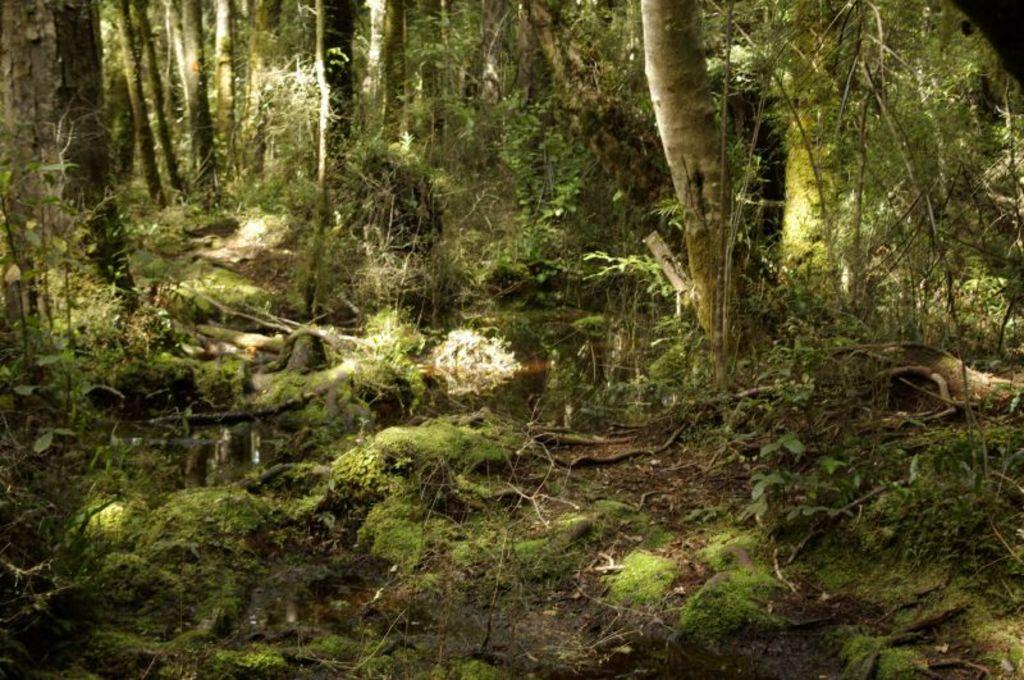What type of vegetation is present in the image? There is grass in the image. What natural element can be seen besides the grass? There is water visible in the image. What can be seen in the distance in the image? There are trees in the background of the image. Can you see a yoke being used in the image? There is no yoke present in the image. Is there a scene in the image where someone is kissing another person? There is no kissing scene present in the image. 